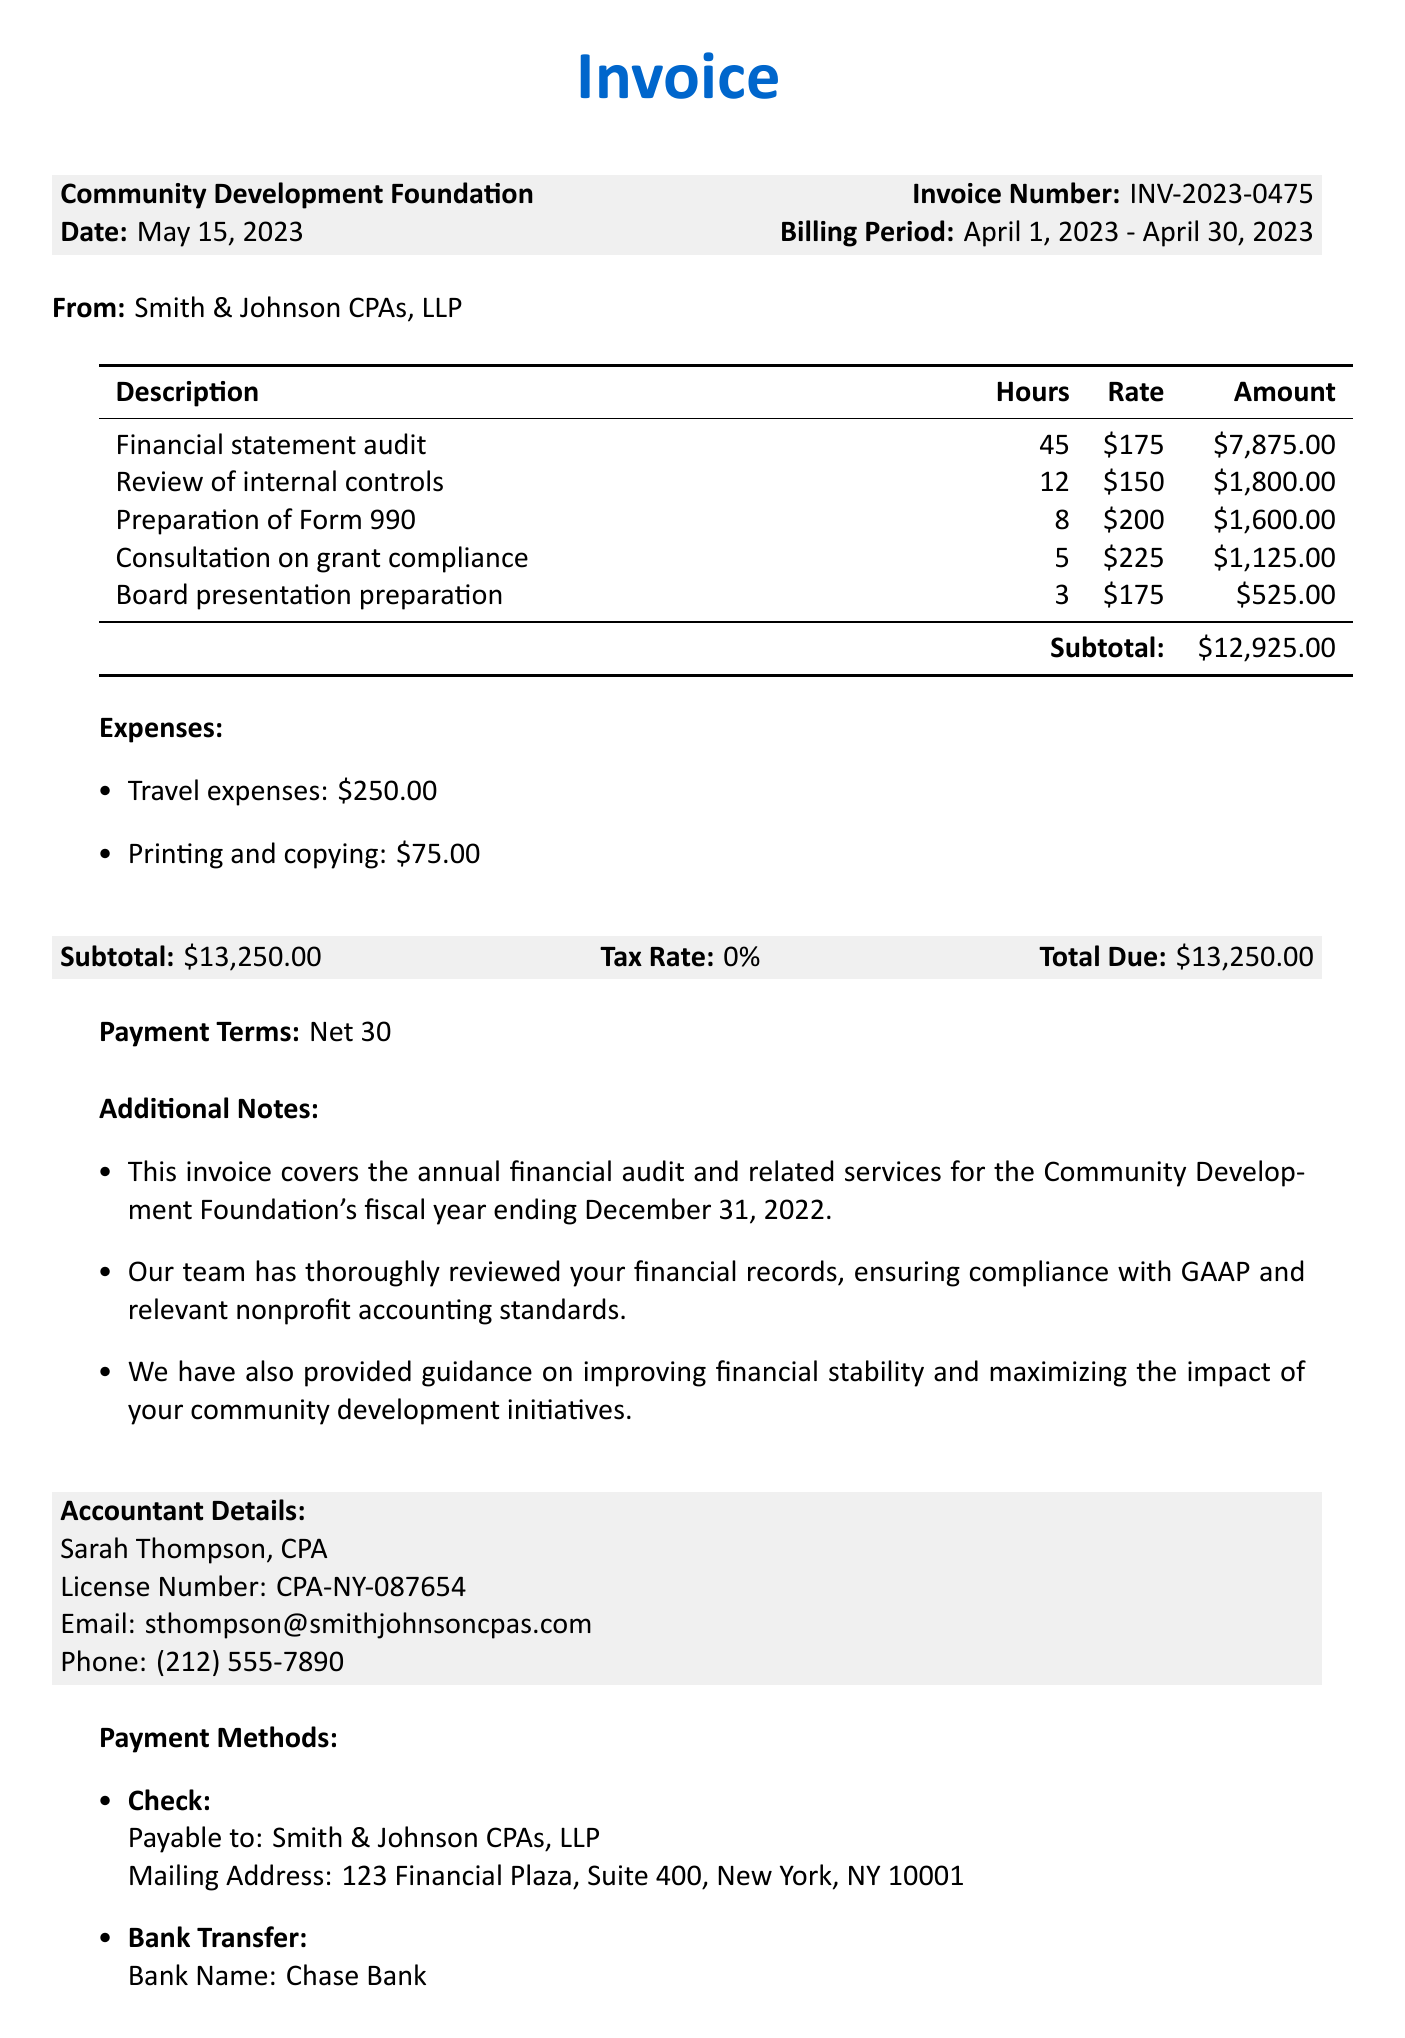What is the organization name? The organization name is mentioned prominently at the top of the invoice as "Community Development Foundation."
Answer: Community Development Foundation Who is the accountant? The accountant's name and designation is listed below the invoice details, where it says "Sarah Thompson, CPA."
Answer: Sarah Thompson, CPA What is the invoice number? The invoice number is clearly stated in the document as "INV-2023-0475."
Answer: INV-2023-0475 What is the total amount due? The total amount due is provided at the end of the invoice, stated as "$13,250.00."
Answer: $13,250.00 How many hours were billed for the financial statement audit? The invoice specifies that 45 hours were billed for the financial statement audit.
Answer: 45 hours What is the hourly rate for the preparation of Form 990? The hourly rate for the preparation of Form 990 is given as "$200."
Answer: $200 What is the payment term? The payment term is explicitly noted in the document as "Net 30."
Answer: Net 30 What additional guidance did the accountant provide? The additional notes mention guidance on "improving financial stability and maximizing the impact of your community development initiatives."
Answer: Improving financial stability and maximizing impact What is the mailing address for payment by check? The mailing address for check payment is provided in the payment methods section as "123 Financial Plaza, Suite 400, New York, NY 10001."
Answer: 123 Financial Plaza, Suite 400, New York, NY 10001 